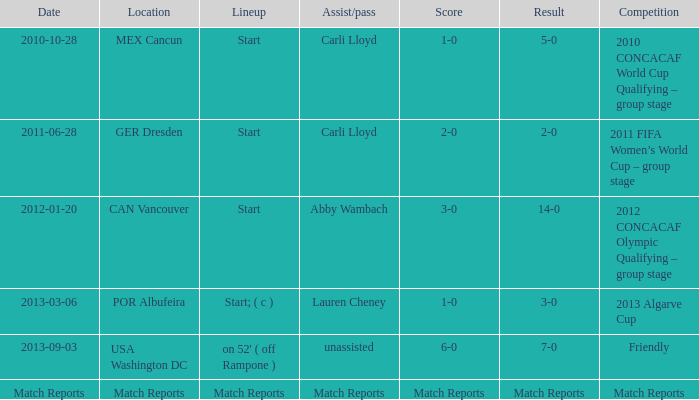Name the Lineup that has an Assist/pass of carli lloyd,a Competition of 2010 concacaf world cup qualifying – group stage? Start. 